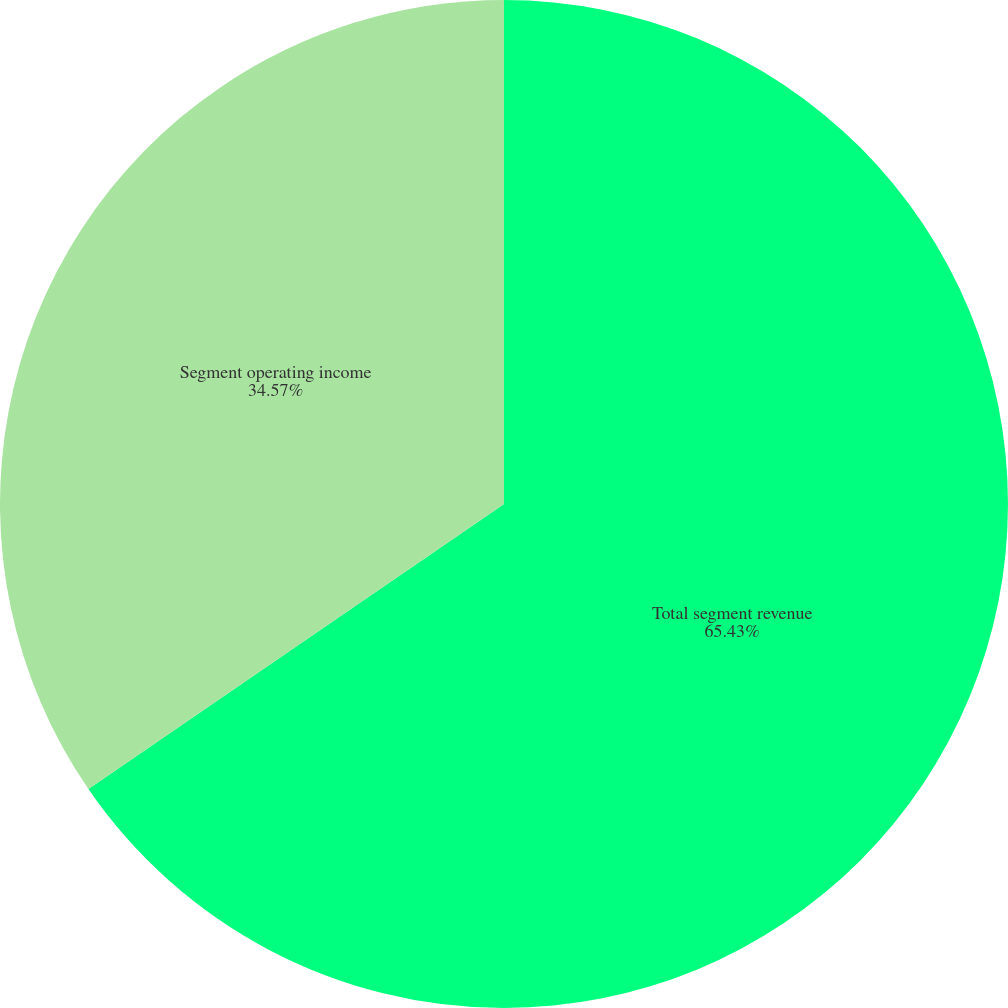Convert chart. <chart><loc_0><loc_0><loc_500><loc_500><pie_chart><fcel>Total segment revenue<fcel>Segment operating income<nl><fcel>65.43%<fcel>34.57%<nl></chart> 